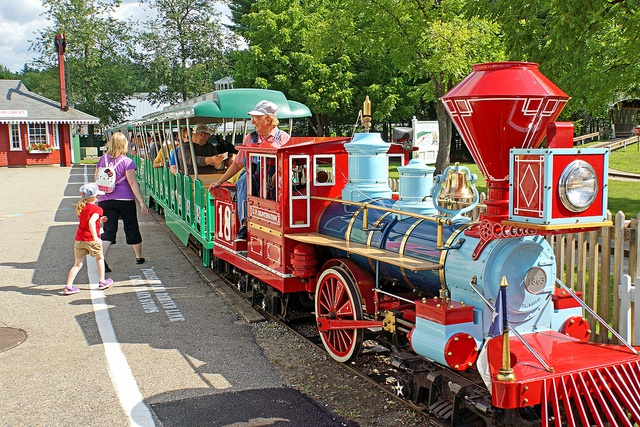Describe the objects in this image and their specific colors. I can see train in lightgray, black, brown, white, and maroon tones, people in lightgray, black, purple, and darkgray tones, people in lightgray, white, red, tan, and darkgray tones, people in lightgray, brown, and lightpink tones, and people in lightgray, black, gray, and maroon tones in this image. 